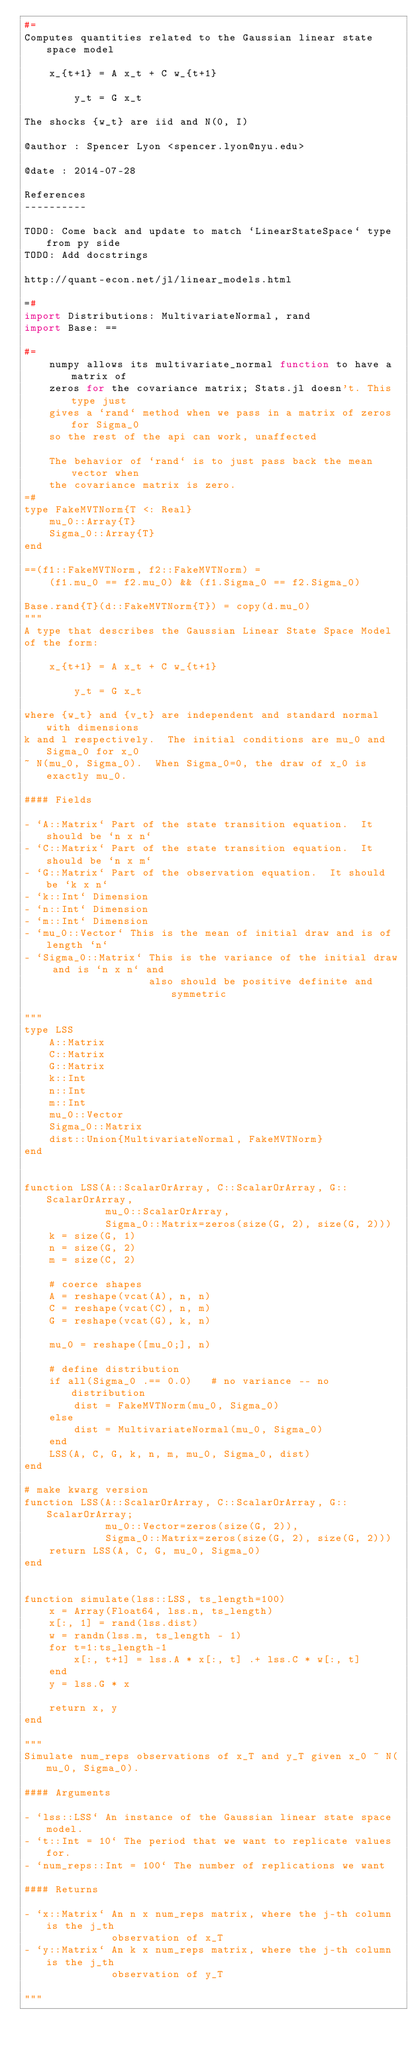Convert code to text. <code><loc_0><loc_0><loc_500><loc_500><_Julia_>#=
Computes quantities related to the Gaussian linear state space model

    x_{t+1} = A x_t + C w_{t+1}

        y_t = G x_t

The shocks {w_t} are iid and N(0, I)

@author : Spencer Lyon <spencer.lyon@nyu.edu>

@date : 2014-07-28

References
----------

TODO: Come back and update to match `LinearStateSpace` type from py side
TODO: Add docstrings

http://quant-econ.net/jl/linear_models.html

=#
import Distributions: MultivariateNormal, rand
import Base: ==

#=
    numpy allows its multivariate_normal function to have a matrix of
    zeros for the covariance matrix; Stats.jl doesn't. This type just
    gives a `rand` method when we pass in a matrix of zeros for Sigma_0
    so the rest of the api can work, unaffected

    The behavior of `rand` is to just pass back the mean vector when
    the covariance matrix is zero.
=#
type FakeMVTNorm{T <: Real}
    mu_0::Array{T}
    Sigma_0::Array{T}
end

==(f1::FakeMVTNorm, f2::FakeMVTNorm) =
    (f1.mu_0 == f2.mu_0) && (f1.Sigma_0 == f2.Sigma_0)

Base.rand{T}(d::FakeMVTNorm{T}) = copy(d.mu_0)
"""
A type that describes the Gaussian Linear State Space Model
of the form:

    x_{t+1} = A x_t + C w_{t+1}

        y_t = G x_t

where {w_t} and {v_t} are independent and standard normal with dimensions
k and l respectively.  The initial conditions are mu_0 and Sigma_0 for x_0
~ N(mu_0, Sigma_0).  When Sigma_0=0, the draw of x_0 is exactly mu_0.

#### Fields

- `A::Matrix` Part of the state transition equation.  It should be `n x n`
- `C::Matrix` Part of the state transition equation.  It should be `n x m`
- `G::Matrix` Part of the observation equation.  It should be `k x n`
- `k::Int` Dimension
- `n::Int` Dimension
- `m::Int` Dimension
- `mu_0::Vector` This is the mean of initial draw and is of length `n`
- `Sigma_0::Matrix` This is the variance of the initial draw and is `n x n` and
                    also should be positive definite and symmetric

"""
type LSS
    A::Matrix
    C::Matrix
    G::Matrix
    k::Int
    n::Int
    m::Int
    mu_0::Vector
    Sigma_0::Matrix
    dist::Union{MultivariateNormal, FakeMVTNorm}
end


function LSS(A::ScalarOrArray, C::ScalarOrArray, G::ScalarOrArray,
             mu_0::ScalarOrArray,
             Sigma_0::Matrix=zeros(size(G, 2), size(G, 2)))
    k = size(G, 1)
    n = size(G, 2)
    m = size(C, 2)

    # coerce shapes
    A = reshape(vcat(A), n, n)
    C = reshape(vcat(C), n, m)
    G = reshape(vcat(G), k, n)

    mu_0 = reshape([mu_0;], n)

    # define distribution
    if all(Sigma_0 .== 0.0)   # no variance -- no distribution
        dist = FakeMVTNorm(mu_0, Sigma_0)
    else
        dist = MultivariateNormal(mu_0, Sigma_0)
    end
    LSS(A, C, G, k, n, m, mu_0, Sigma_0, dist)
end

# make kwarg version
function LSS(A::ScalarOrArray, C::ScalarOrArray, G::ScalarOrArray;
             mu_0::Vector=zeros(size(G, 2)),
             Sigma_0::Matrix=zeros(size(G, 2), size(G, 2)))
    return LSS(A, C, G, mu_0, Sigma_0)
end


function simulate(lss::LSS, ts_length=100)
    x = Array(Float64, lss.n, ts_length)
    x[:, 1] = rand(lss.dist)
    w = randn(lss.m, ts_length - 1)
    for t=1:ts_length-1
        x[:, t+1] = lss.A * x[:, t] .+ lss.C * w[:, t]
    end
    y = lss.G * x

    return x, y
end

"""
Simulate num_reps observations of x_T and y_T given x_0 ~ N(mu_0, Sigma_0).

#### Arguments

- `lss::LSS` An instance of the Gaussian linear state space model.
- `t::Int = 10` The period that we want to replicate values for.
- `num_reps::Int = 100` The number of replications we want

#### Returns

- `x::Matrix` An n x num_reps matrix, where the j-th column is the j_th
              observation of x_T
- `y::Matrix` An k x num_reps matrix, where the j-th column is the j_th
              observation of y_T

"""</code> 